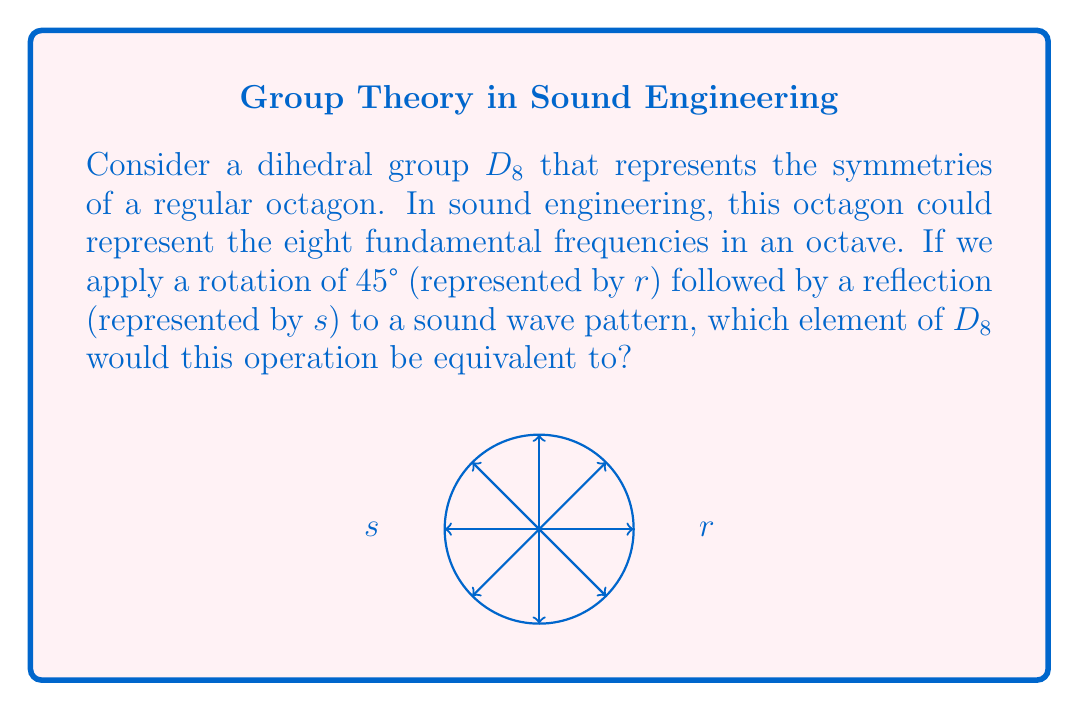Give your solution to this math problem. Let's approach this step-by-step:

1) In the dihedral group $D_8$, we have:
   - Rotations: $r^0, r^1, r^2, r^3, r^4, r^5, r^6, r^7$
   - Reflections: $s, sr, sr^2, sr^3, sr^4, sr^5, sr^6, sr^7$

2) The operation described is a rotation of 45° followed by a reflection. In group theory notation, this is $sr$.

3) To find what this is equivalent to, we need to use the fundamental relations in $D_8$:
   - $r^8 = e$ (identity)
   - $s^2 = e$
   - $srs = r^{-1}$

4) Using the last relation, we can rewrite $sr$ as:
   $sr = sr \cdot e = sr \cdot s^2 = s(rs)s = s(r^{-1})$

5) In $D_8$, $r^{-1} = r^7$ (because $r^8 = e$)

6) Therefore, $sr = sr^7$

This means that applying a 45° rotation followed by a reflection is equivalent to applying a reflection followed by a 315° rotation (seven 45° rotations in the opposite direction).
Answer: $sr^7$ 